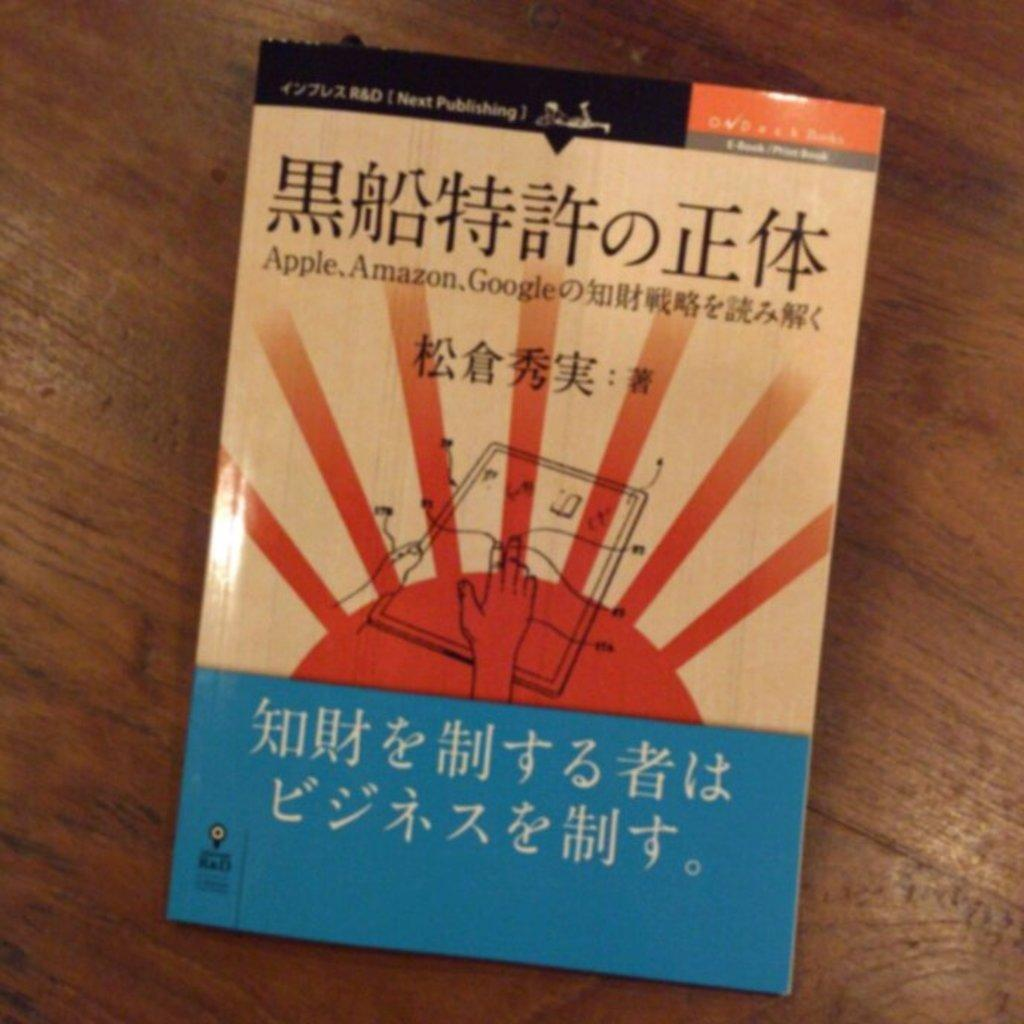<image>
Render a clear and concise summary of the photo. An asian textbook sits on a wooden surface. 